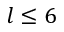<formula> <loc_0><loc_0><loc_500><loc_500>l \leq 6</formula> 